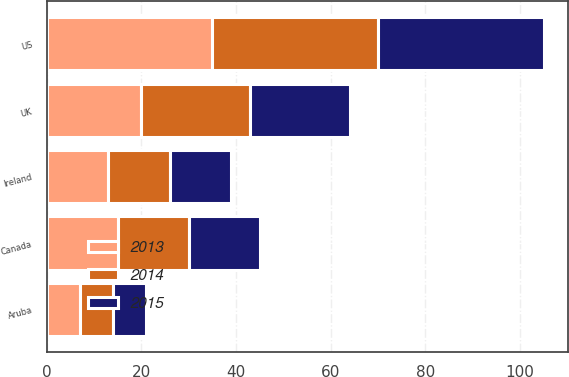<chart> <loc_0><loc_0><loc_500><loc_500><stacked_bar_chart><ecel><fcel>US<fcel>Canada<fcel>UK<fcel>Ireland<fcel>Aruba<nl><fcel>2013<fcel>35<fcel>15<fcel>20<fcel>13<fcel>7<nl><fcel>2015<fcel>35<fcel>15<fcel>21<fcel>13<fcel>7<nl><fcel>2014<fcel>35<fcel>15<fcel>23<fcel>13<fcel>7<nl></chart> 